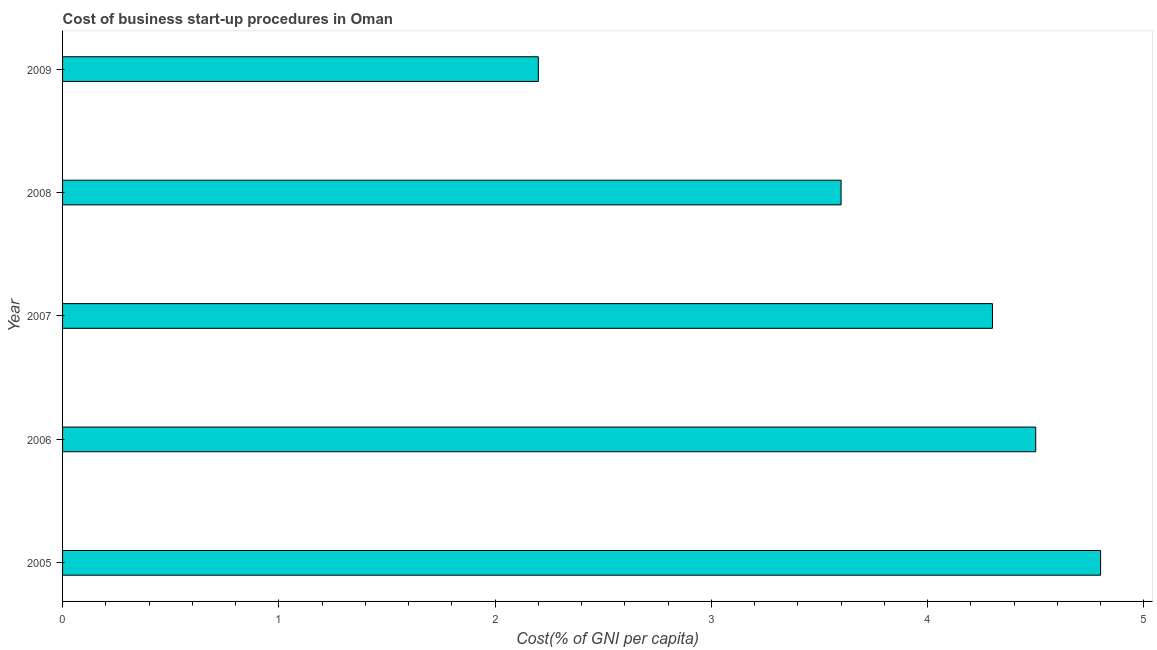Does the graph contain any zero values?
Ensure brevity in your answer.  No. What is the title of the graph?
Offer a very short reply. Cost of business start-up procedures in Oman. What is the label or title of the X-axis?
Offer a terse response. Cost(% of GNI per capita). What is the label or title of the Y-axis?
Your answer should be very brief. Year. What is the cost of business startup procedures in 2007?
Give a very brief answer. 4.3. Across all years, what is the minimum cost of business startup procedures?
Your response must be concise. 2.2. In which year was the cost of business startup procedures maximum?
Your response must be concise. 2005. What is the sum of the cost of business startup procedures?
Your answer should be very brief. 19.4. What is the average cost of business startup procedures per year?
Offer a very short reply. 3.88. In how many years, is the cost of business startup procedures greater than 2.6 %?
Offer a terse response. 4. Do a majority of the years between 2009 and 2007 (inclusive) have cost of business startup procedures greater than 3.4 %?
Your answer should be compact. Yes. What is the ratio of the cost of business startup procedures in 2006 to that in 2007?
Your answer should be compact. 1.05. Is the cost of business startup procedures in 2007 less than that in 2009?
Your answer should be very brief. No. Is the sum of the cost of business startup procedures in 2007 and 2008 greater than the maximum cost of business startup procedures across all years?
Offer a very short reply. Yes. What is the difference between the highest and the lowest cost of business startup procedures?
Provide a succinct answer. 2.6. Are all the bars in the graph horizontal?
Offer a very short reply. Yes. How many years are there in the graph?
Provide a short and direct response. 5. Are the values on the major ticks of X-axis written in scientific E-notation?
Provide a succinct answer. No. What is the Cost(% of GNI per capita) in 2006?
Your answer should be very brief. 4.5. What is the Cost(% of GNI per capita) in 2007?
Offer a terse response. 4.3. What is the Cost(% of GNI per capita) of 2009?
Offer a very short reply. 2.2. What is the difference between the Cost(% of GNI per capita) in 2005 and 2006?
Give a very brief answer. 0.3. What is the difference between the Cost(% of GNI per capita) in 2007 and 2008?
Give a very brief answer. 0.7. What is the difference between the Cost(% of GNI per capita) in 2007 and 2009?
Ensure brevity in your answer.  2.1. What is the difference between the Cost(% of GNI per capita) in 2008 and 2009?
Offer a terse response. 1.4. What is the ratio of the Cost(% of GNI per capita) in 2005 to that in 2006?
Offer a very short reply. 1.07. What is the ratio of the Cost(% of GNI per capita) in 2005 to that in 2007?
Provide a succinct answer. 1.12. What is the ratio of the Cost(% of GNI per capita) in 2005 to that in 2008?
Offer a terse response. 1.33. What is the ratio of the Cost(% of GNI per capita) in 2005 to that in 2009?
Your response must be concise. 2.18. What is the ratio of the Cost(% of GNI per capita) in 2006 to that in 2007?
Your answer should be very brief. 1.05. What is the ratio of the Cost(% of GNI per capita) in 2006 to that in 2009?
Your answer should be very brief. 2.04. What is the ratio of the Cost(% of GNI per capita) in 2007 to that in 2008?
Offer a terse response. 1.19. What is the ratio of the Cost(% of GNI per capita) in 2007 to that in 2009?
Provide a short and direct response. 1.96. What is the ratio of the Cost(% of GNI per capita) in 2008 to that in 2009?
Ensure brevity in your answer.  1.64. 